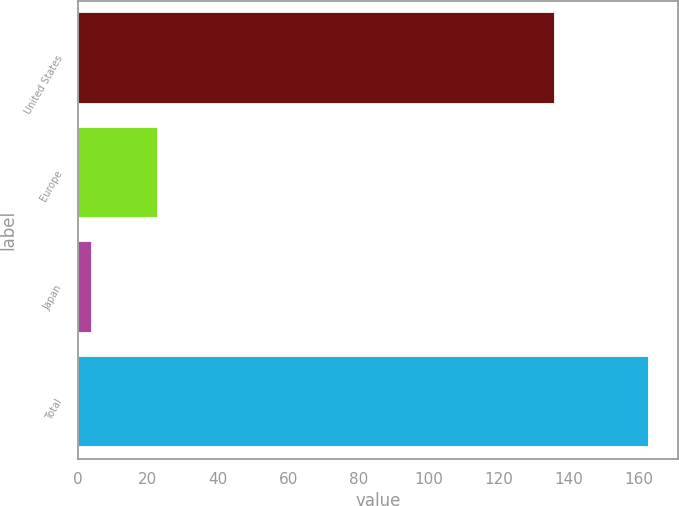Convert chart to OTSL. <chart><loc_0><loc_0><loc_500><loc_500><bar_chart><fcel>United States<fcel>Europe<fcel>Japan<fcel>Total<nl><fcel>136<fcel>23<fcel>4<fcel>163<nl></chart> 